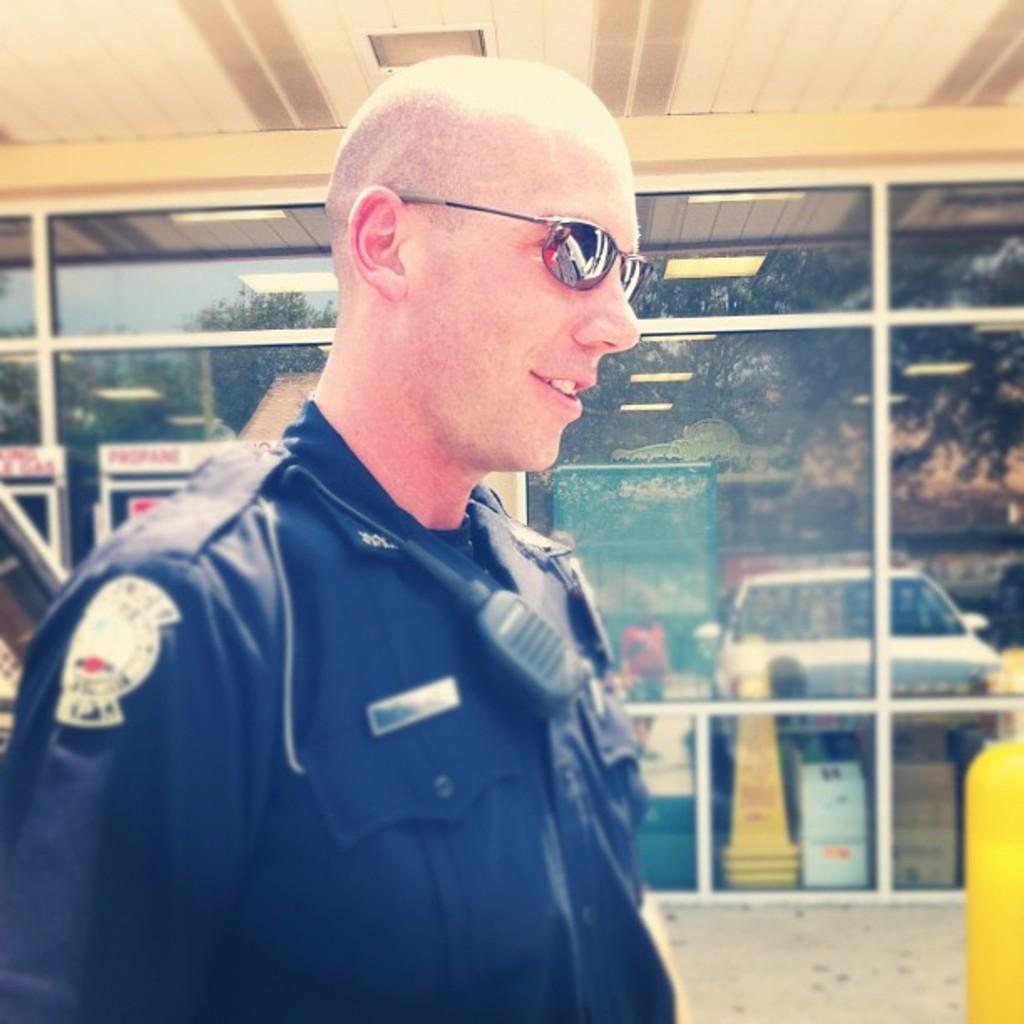Describe this image in one or two sentences. In this image there is a person wearing goggles. Behind him there is a glass wall having the reflection of a vehicle, person, few trees and building. 